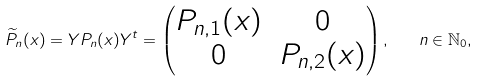<formula> <loc_0><loc_0><loc_500><loc_500>\widetilde { P } _ { n } ( x ) = Y P _ { n } ( x ) Y ^ { t } = \begin{pmatrix} P _ { n , 1 } ( x ) & 0 \\ 0 & P _ { n , 2 } ( x ) \end{pmatrix} , \quad n \in \mathbb { N } _ { 0 } ,</formula> 